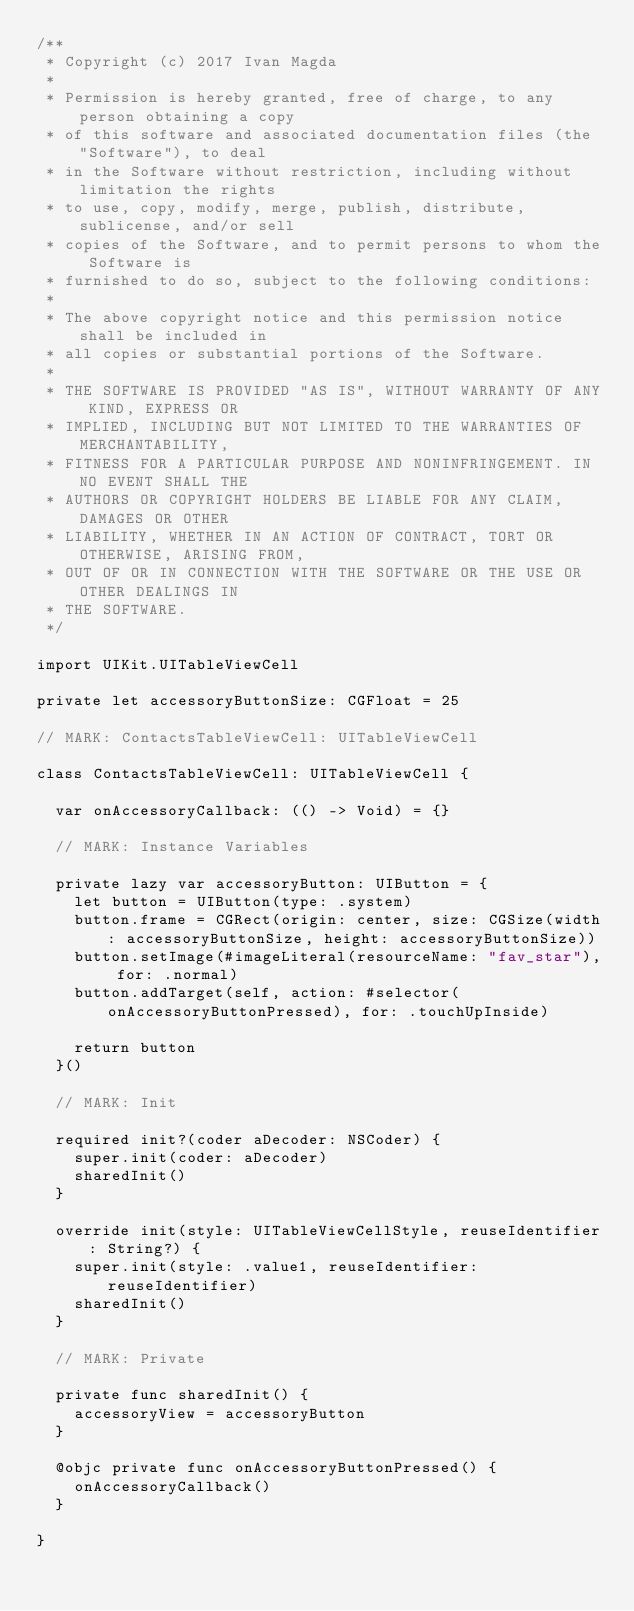<code> <loc_0><loc_0><loc_500><loc_500><_Swift_>/**
 * Copyright (c) 2017 Ivan Magda
 *
 * Permission is hereby granted, free of charge, to any person obtaining a copy
 * of this software and associated documentation files (the "Software"), to deal
 * in the Software without restriction, including without limitation the rights
 * to use, copy, modify, merge, publish, distribute, sublicense, and/or sell
 * copies of the Software, and to permit persons to whom the Software is
 * furnished to do so, subject to the following conditions:
 *
 * The above copyright notice and this permission notice shall be included in
 * all copies or substantial portions of the Software.
 *
 * THE SOFTWARE IS PROVIDED "AS IS", WITHOUT WARRANTY OF ANY KIND, EXPRESS OR
 * IMPLIED, INCLUDING BUT NOT LIMITED TO THE WARRANTIES OF MERCHANTABILITY,
 * FITNESS FOR A PARTICULAR PURPOSE AND NONINFRINGEMENT. IN NO EVENT SHALL THE
 * AUTHORS OR COPYRIGHT HOLDERS BE LIABLE FOR ANY CLAIM, DAMAGES OR OTHER
 * LIABILITY, WHETHER IN AN ACTION OF CONTRACT, TORT OR OTHERWISE, ARISING FROM,
 * OUT OF OR IN CONNECTION WITH THE SOFTWARE OR THE USE OR OTHER DEALINGS IN
 * THE SOFTWARE.
 */

import UIKit.UITableViewCell

private let accessoryButtonSize: CGFloat = 25

// MARK: ContactsTableViewCell: UITableViewCell

class ContactsTableViewCell: UITableViewCell {

  var onAccessoryCallback: (() -> Void) = {}

  // MARK: Instance Variables

  private lazy var accessoryButton: UIButton = {
    let button = UIButton(type: .system)
    button.frame = CGRect(origin: center, size: CGSize(width: accessoryButtonSize, height: accessoryButtonSize))
    button.setImage(#imageLiteral(resourceName: "fav_star"), for: .normal)
    button.addTarget(self, action: #selector(onAccessoryButtonPressed), for: .touchUpInside)

    return button
  }()

  // MARK: Init

  required init?(coder aDecoder: NSCoder) {
    super.init(coder: aDecoder)
    sharedInit()
  }

  override init(style: UITableViewCellStyle, reuseIdentifier: String?) {
    super.init(style: .value1, reuseIdentifier: reuseIdentifier)
    sharedInit()
  }

  // MARK: Private

  private func sharedInit() {
    accessoryView = accessoryButton
  }

  @objc private func onAccessoryButtonPressed() {
    onAccessoryCallback()
  }

}
</code> 